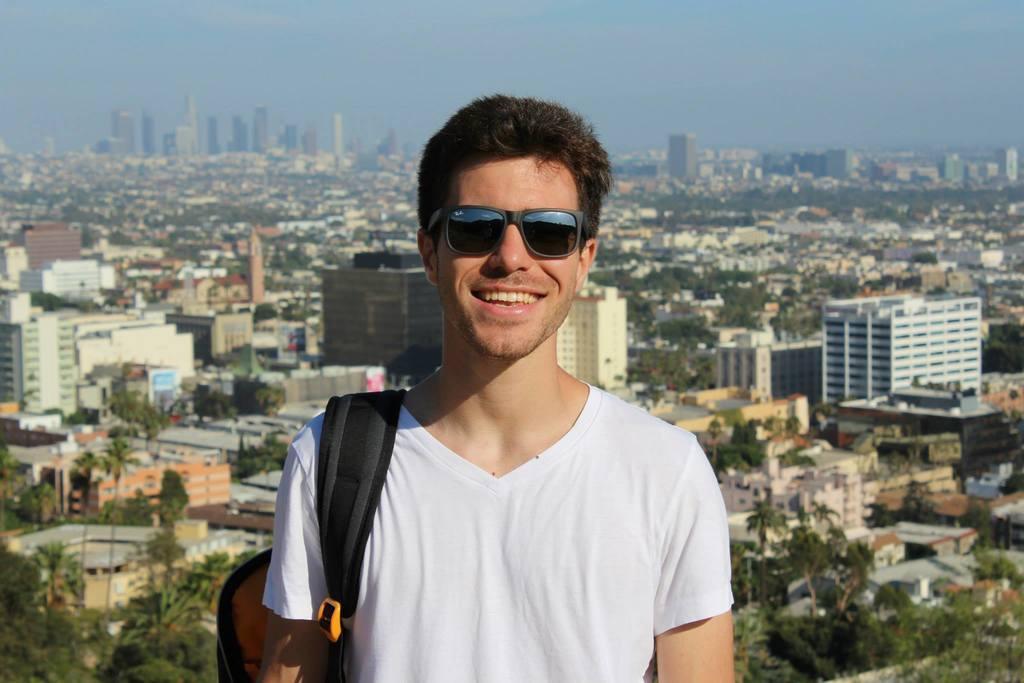Can you describe this image briefly? In the foreground of this image, there is a man standing and wearing a bag pack and having smile on his face. In the background, we can see the city which includes the buildings and trees. On the top, there is the sky. 